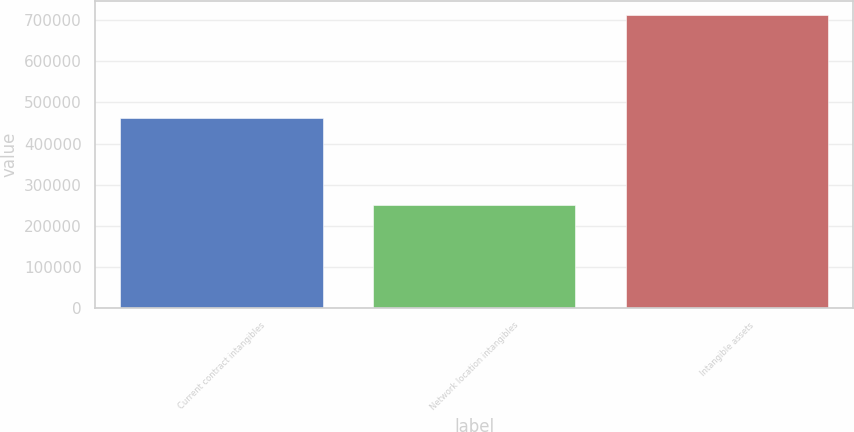Convert chart to OTSL. <chart><loc_0><loc_0><loc_500><loc_500><bar_chart><fcel>Current contract intangibles<fcel>Network location intangibles<fcel>Intangible assets<nl><fcel>462016<fcel>250385<fcel>712401<nl></chart> 